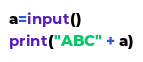Convert code to text. <code><loc_0><loc_0><loc_500><loc_500><_Python_>a=input()
print("ABC" + a)</code> 